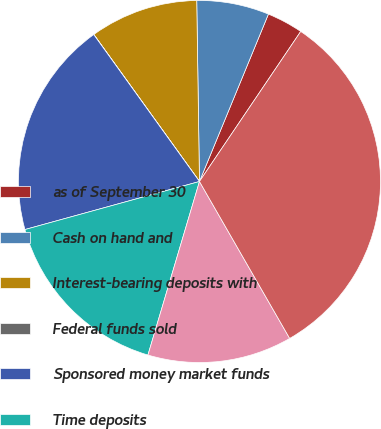Convert chart to OTSL. <chart><loc_0><loc_0><loc_500><loc_500><pie_chart><fcel>as of September 30<fcel>Cash on hand and<fcel>Interest-bearing deposits with<fcel>Federal funds sold<fcel>Sponsored money market funds<fcel>Time deposits<fcel>Securities of the US Treasury<fcel>Total<nl><fcel>3.23%<fcel>6.46%<fcel>9.68%<fcel>0.01%<fcel>19.35%<fcel>16.13%<fcel>12.9%<fcel>32.25%<nl></chart> 